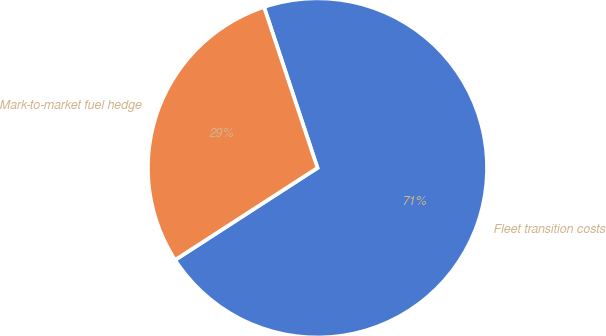<chart> <loc_0><loc_0><loc_500><loc_500><pie_chart><fcel>Fleet transition costs<fcel>Mark-to-market fuel hedge<nl><fcel>70.97%<fcel>29.03%<nl></chart> 